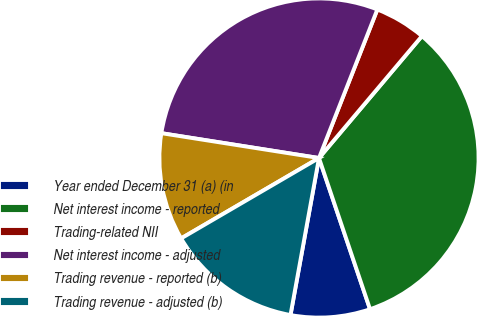Convert chart. <chart><loc_0><loc_0><loc_500><loc_500><pie_chart><fcel>Year ended December 31 (a) (in<fcel>Net interest income - reported<fcel>Trading-related NII<fcel>Net interest income - adjusted<fcel>Trading revenue - reported (b)<fcel>Trading revenue - adjusted (b)<nl><fcel>8.04%<fcel>33.66%<fcel>5.2%<fcel>28.47%<fcel>10.89%<fcel>13.74%<nl></chart> 